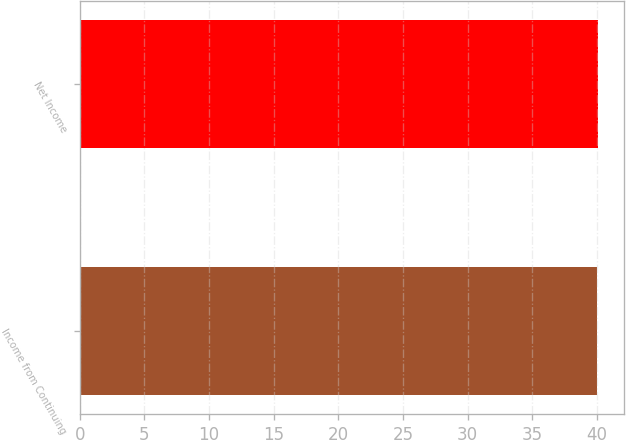Convert chart to OTSL. <chart><loc_0><loc_0><loc_500><loc_500><bar_chart><fcel>Income from Continuing<fcel>Net Income<nl><fcel>40<fcel>40.1<nl></chart> 